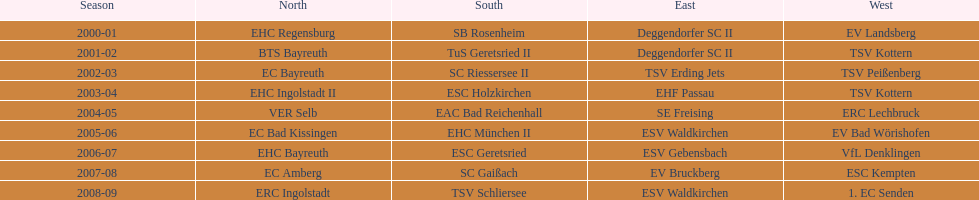Which teams emerged as winners in the north in their corresponding years? 2000-01, EHC Regensburg, BTS Bayreuth, EC Bayreuth, EHC Ingolstadt II, VER Selb, EC Bad Kissingen, EHC Bayreuth, EC Amberg, ERC Ingolstadt. Which team's victory was limited to the 2000-01 season? EHC Regensburg. 